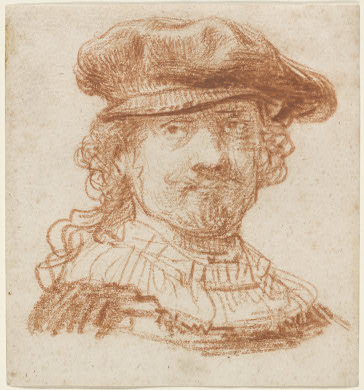Based on the artistic style and medium, who could be the possible artist of this portrait? Given the distinctive use of red chalk and the Baroque style, along with the expertly crafted portrait that highlights texture and expression, one might speculate that this artwork could be attributed to a master of the Baroque period, potentially Rembrandt van Rijn. Rembrandt frequently used red chalk in his drawings and was known for his keen ability to capture the emotional depth and personality of his subjects. His portraits often feature dramatic contrasts and intricate details, similar to those seen in this image. 